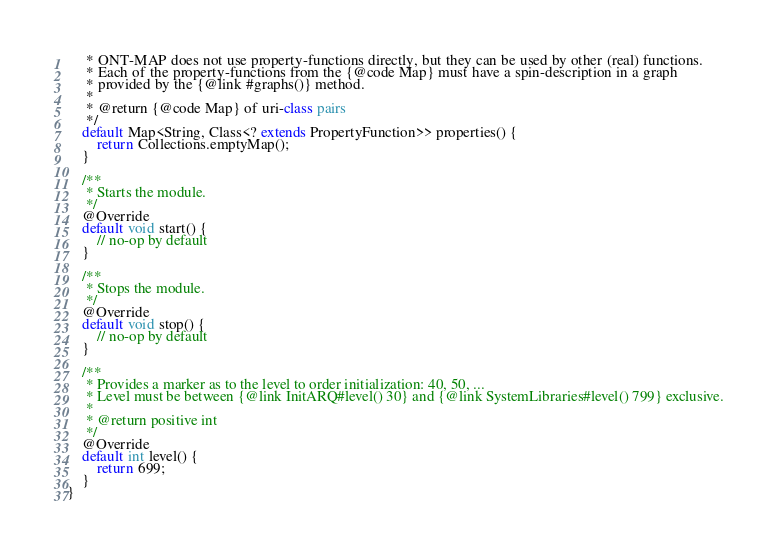Convert code to text. <code><loc_0><loc_0><loc_500><loc_500><_Java_>     * ONT-MAP does not use property-functions directly, but they can be used by other (real) functions.
     * Each of the property-functions from the {@code Map} must have a spin-description in a graph
     * provided by the {@link #graphs()} method.
     *
     * @return {@code Map} of uri-class pairs
     */
    default Map<String, Class<? extends PropertyFunction>> properties() {
        return Collections.emptyMap();
    }

    /**
     * Starts the module.
     */
    @Override
    default void start() {
        // no-op by default
    }

    /**
     * Stops the module.
     */
    @Override
    default void stop() {
        // no-op by default
    }

    /**
     * Provides a marker as to the level to order initialization: 40, 50, ...
     * Level must be between {@link InitARQ#level() 30} and {@link SystemLibraries#level() 799} exclusive.
     *
     * @return positive int
     */
    @Override
    default int level() {
        return 699;
    }
}
</code> 